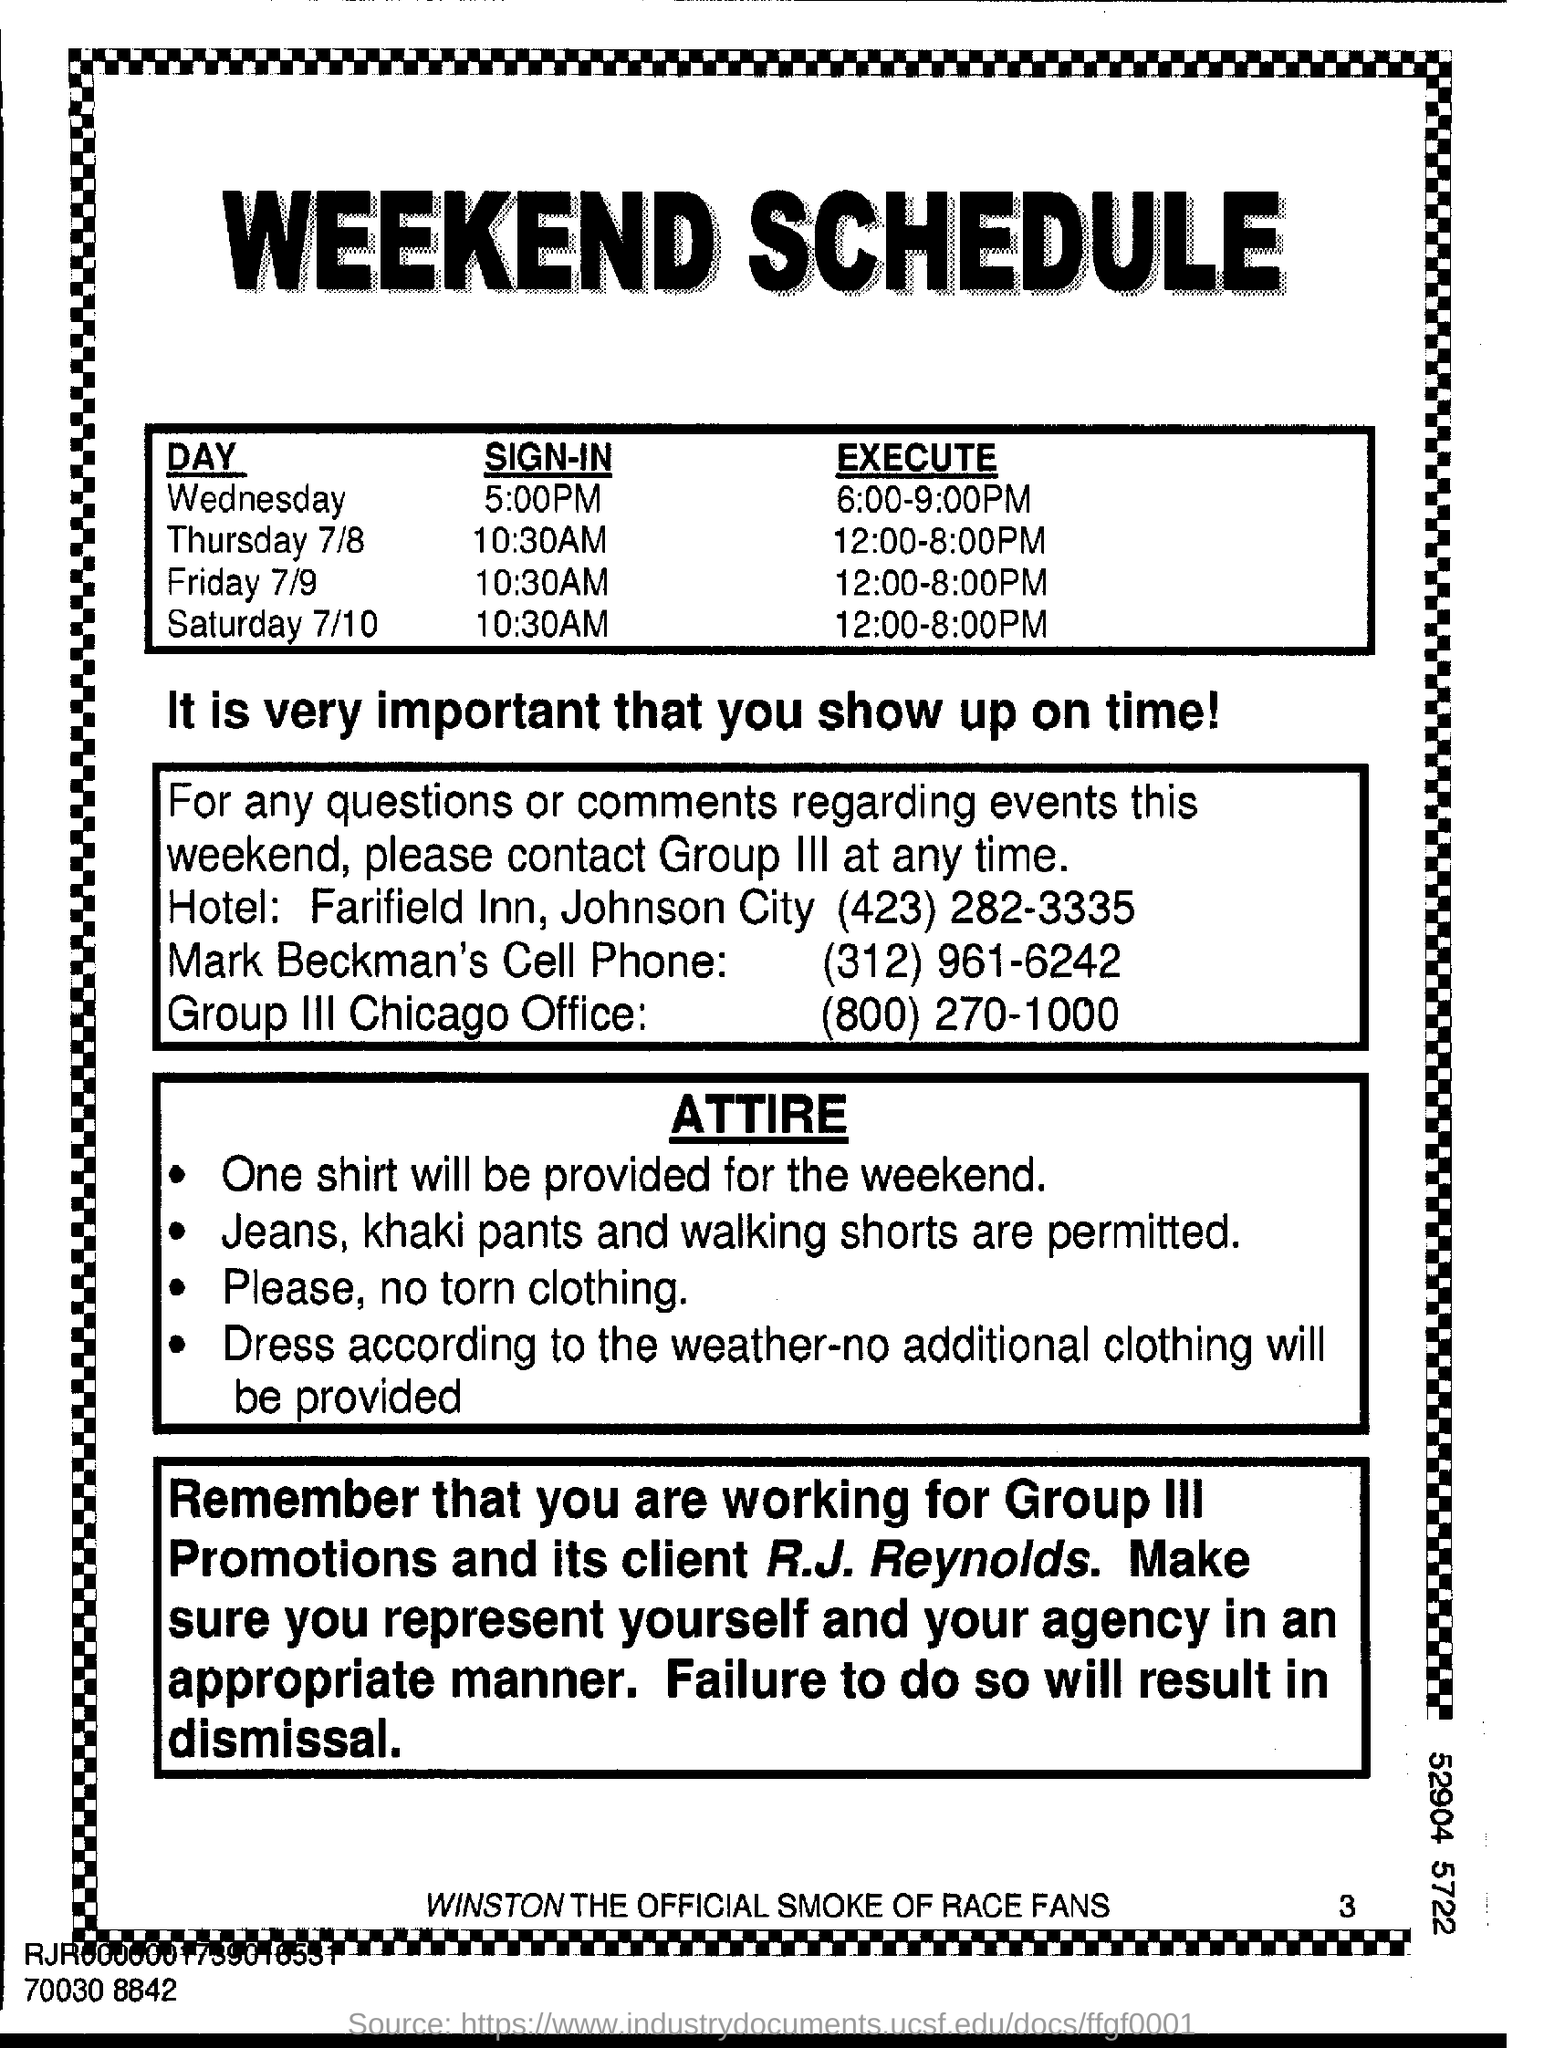What type of clothes are prohibited?
Give a very brief answer. Torn clothing. What will be provided for the weekend?
Your answer should be very brief. One shirt. 